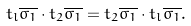Convert formula to latex. <formula><loc_0><loc_0><loc_500><loc_500>t _ { l } \overline { \sigma _ { 1 } } \cdot t _ { 2 } \overline { \sigma _ { 1 } } = t _ { 2 } \overline { \sigma _ { 1 } } \cdot t _ { l } \overline { \sigma _ { 1 } } .</formula> 